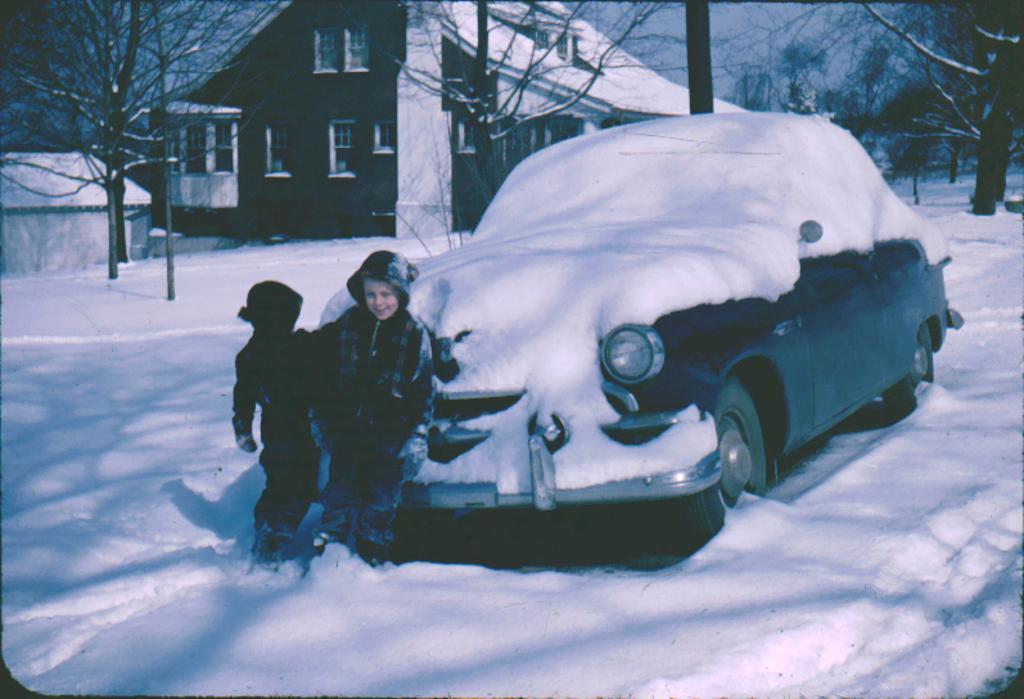In one or two sentences, can you explain what this image depicts? It is the black and white image in which there is a car in the snow. The car is covered by the snow. In front of the car there are two kids. In the background there is a house and trees beside it which are covered with the snow. 